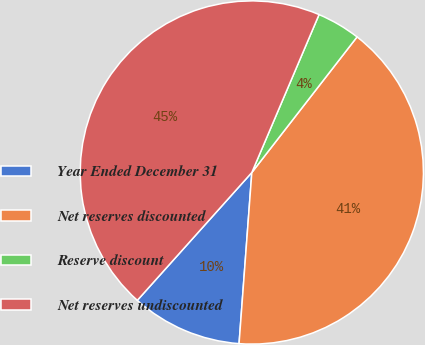Convert chart to OTSL. <chart><loc_0><loc_0><loc_500><loc_500><pie_chart><fcel>Year Ended December 31<fcel>Net reserves discounted<fcel>Reserve discount<fcel>Net reserves undiscounted<nl><fcel>10.44%<fcel>40.68%<fcel>4.1%<fcel>44.78%<nl></chart> 